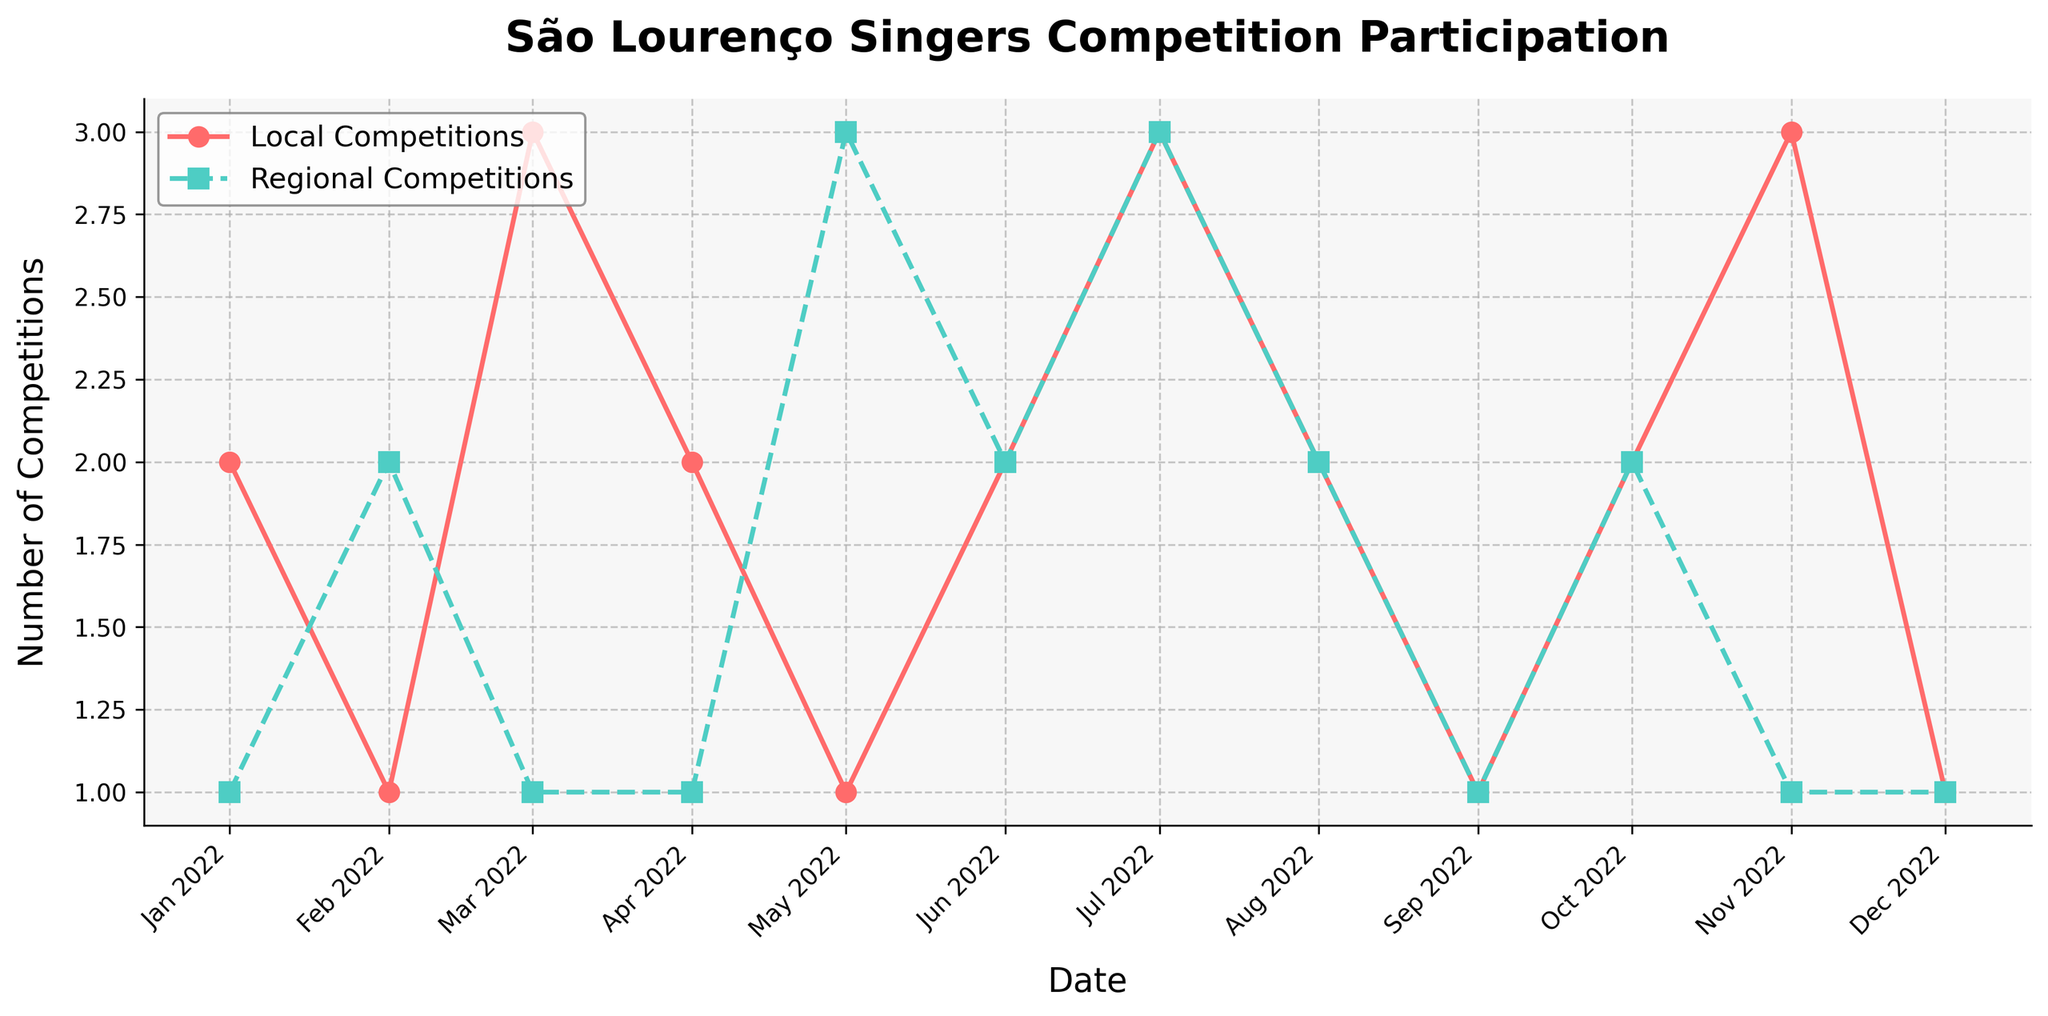What's the title of the plot? The title of the plot is prominently displayed at the top and it summarizes what the plot is about. It reads "São Lourenço Singers Competition Participation".
Answer: São Lourenço Singers Competition Participation How many months are displayed in the time series? To determine how many months are displayed, count each unique date label on the x-axis. Each data point corresponds to one month.
Answer: 12 Which month had the highest number of local competitions? To find this, look at the trendline for local competitions and identify the peak point. March, July, and November have values of 3 each; therefore, these months had the highest number of local competitions.
Answer: March, July, November What is the average number of regional competitions per month over the entire year? Sum the regional competition values for each month, then divide by the number of months (12). The sum is 19, thus the average is 19/12 ≈ 1.58.
Answer: 1.58 How many months had more regional competitions than local competitions? Compare the values for regional and local competitions for each month. February and May are the only months where regional competitions outnumber local competitions.
Answer: 2 In which months did the São Lourenço Singers participate in exactly 2 local and 2 regional competitions? Look for overlapped points where both values are 2. These occur in June, August, and October.
Answer: June, August, October What is the difference in the number of local and regional competitions in May? For May, find the local (1) and regional (3) competition values and calculate the difference (3-1).
Answer: 2 What trend do you notice about local competitions over the year? To identify trends, observe the overall shape and direction of the local competitions line. There are fluctuations but no strong upward or downward trend, with peaks in March, July, and November.
Answer: Fluctuating During which month was the difference between local and regional competitions the greatest? For each month, calculate the absolute difference between the local and regional competitions. May shows the highest difference (3-1=2).
Answer: May How does the participation in competitions in December compare with January? Compare the values for both local and regional competitions between January and December. Both local and regional competitions remained the same (2 for local, 1 for regional in January; 1 for both in December).
Answer: Local decreased, Regional same 